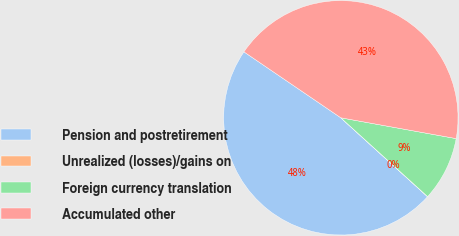Convert chart to OTSL. <chart><loc_0><loc_0><loc_500><loc_500><pie_chart><fcel>Pension and postretirement<fcel>Unrealized (losses)/gains on<fcel>Foreign currency translation<fcel>Accumulated other<nl><fcel>47.76%<fcel>0.02%<fcel>8.89%<fcel>43.33%<nl></chart> 